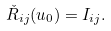Convert formula to latex. <formula><loc_0><loc_0><loc_500><loc_500>\check { R } _ { i j } ( u _ { 0 } ) = I _ { i j } .</formula> 